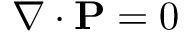Convert formula to latex. <formula><loc_0><loc_0><loc_500><loc_500>\nabla \cdot P = 0</formula> 